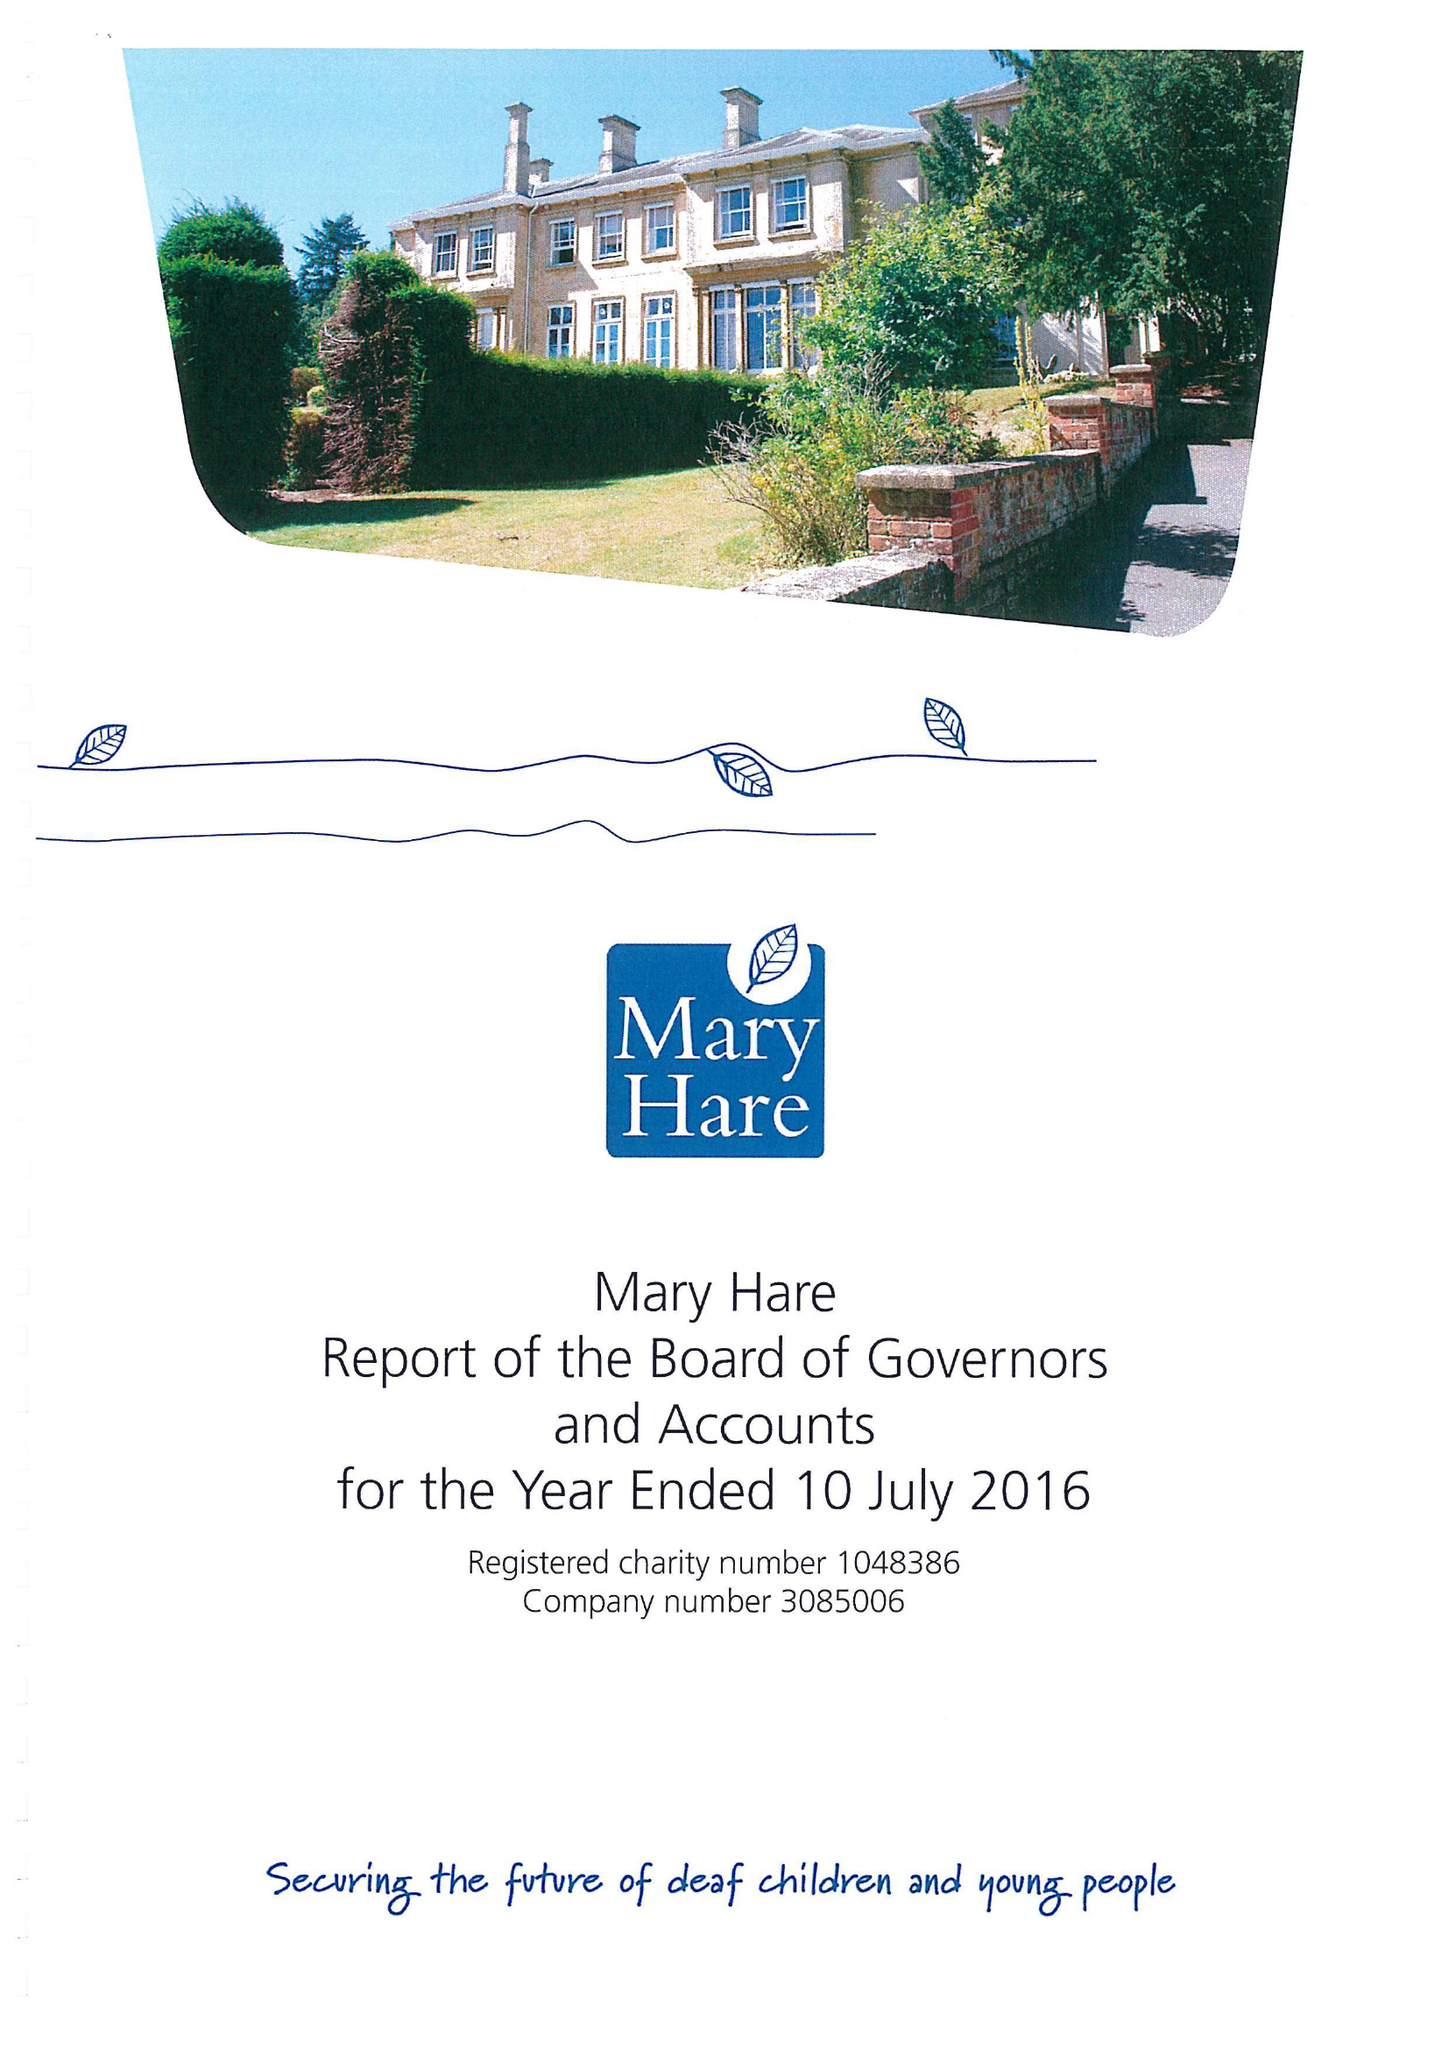What is the value for the address__street_line?
Answer the question using a single word or phrase. NEWBURY 